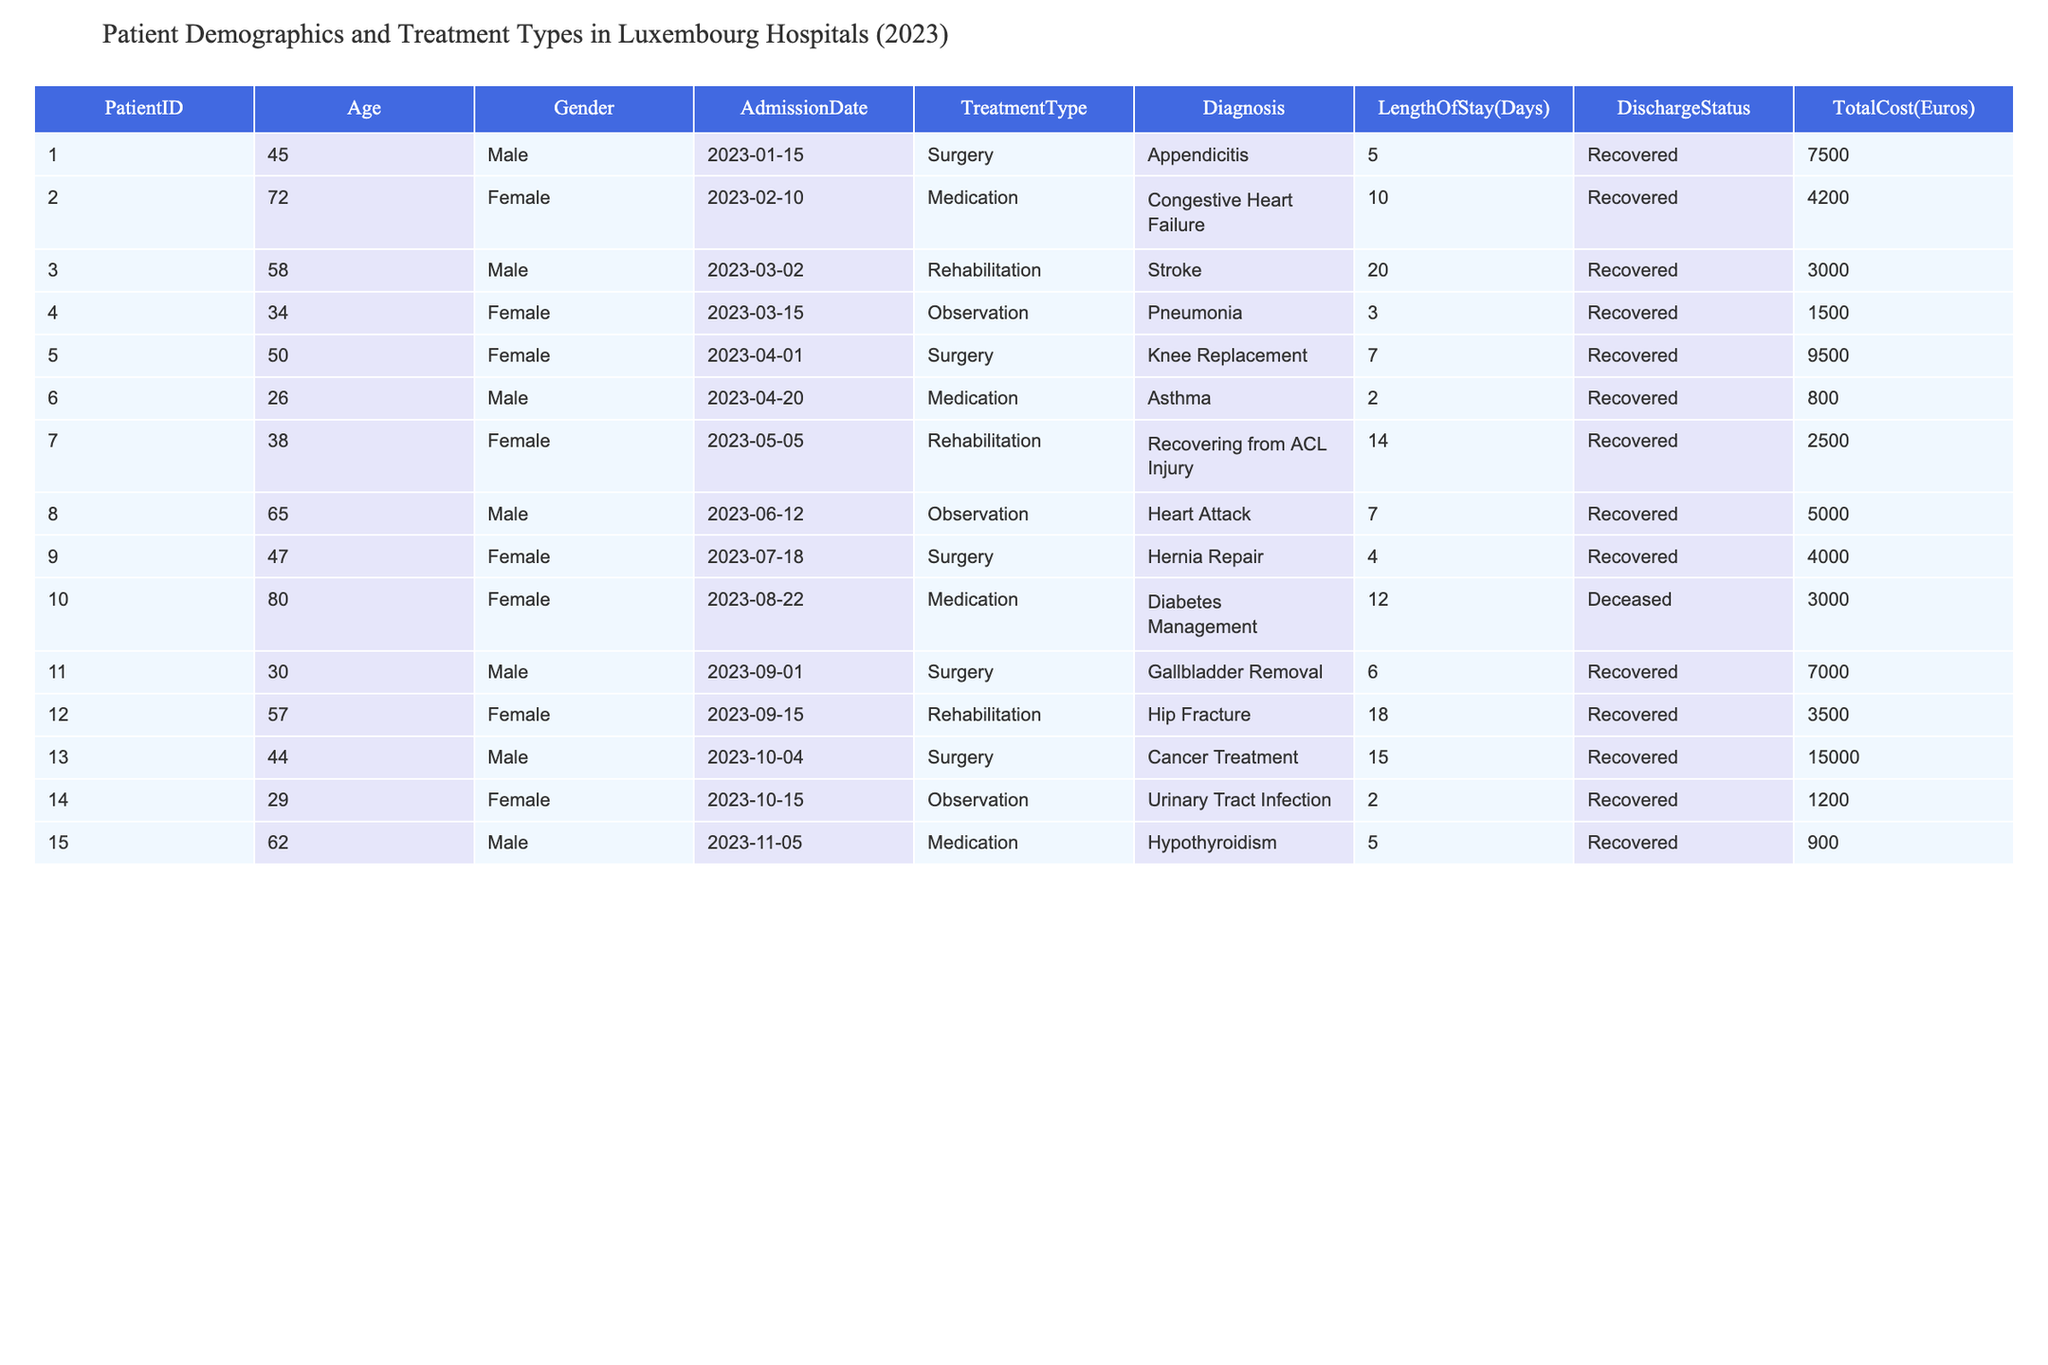What is the total cost of treatment for PatientID 10? The total cost for PatientID 10 is located in the "TotalCost(Euros)" column, which shows a value of 3000.
Answer: 3000 What is the average age of male patients? The ages of male patients are 45, 58, 26, 65, 30, 44, and 62, which sum up to 330. There are 7 male patients, so the average age is 330/7 = approximately 47.14.
Answer: 47.14 How many patients were treated with Rehabilitation? The table lists 3 patients who received Rehabilitation treatment types: PatientID 3, 7, and 12.
Answer: 3 Was the length of stay longer for the patients who underwent Surgery or Medication treatment? The average length of stay for Surgery (5+7+6+15) = 33 days for 4 patients = 8.25 days, and for Medication (10+12+5) = 27 days for 3 patients = 9 days. Thus, Medication had a longer average stay than Surgery.
Answer: Yes What is the total length of stay for all patients with a Discharge Status of 'Recovered'? The total length of stay for 'Recovered' patients can be calculated by adding the associated days: 5+10+20+3+7+2+14+7+4+6+18+15+2+5 = 118 days.
Answer: 118 Is there any patient under 30 years old in the dataset? By checking the "Age" column, the youngest patient has an age of 26 (PatientID 6), confirming that there is at least one patient under 30.
Answer: Yes What percentage of the patients were discharged as 'Deceased'? There is 1 patient who was 'Deceased' (PatientID 10) out of 15 total patients. The percentage is calculated as (1/15)*100, which equals 6.67%.
Answer: 6.67% What is the total cost of treatment for all patients aged 60 and above? The patients aged 60 and above are PatientID 8, 10, and 15, with costs of 5000, 3000, and 900 respectively. Adding these costs gives total = 5000 + 3000 + 900 = 8900.
Answer: 8900 Which gender had the highest average treatment cost? The average treatment cost for male patients is (7500 + 3000 + 800 + 5000 + 7000 + 15000 + 900) = 36100 for 7 males = 5157.14, while for females, it is (4200 + 9500 + 1500 + 4000 + 3000 + 3500 + 1200) = 16200 for 8 females = 2025. Therefore, males had a higher average cost.
Answer: Male How many patients had a length of stay of more than 10 days? Based on the data, the patients with a length of stay greater than 10 days are IDs 2 (10), 3 (20), 12 (18), and 13 (15), totaling 4 patients.
Answer: 4 What was the most common treatment type in the dataset? The count of each treatment type shows Surgery: 6 times, Medication: 4 times, Rehabilitation: 3 times, and Observation: 3 times. Surgery is the most common treatment type.
Answer: Surgery 